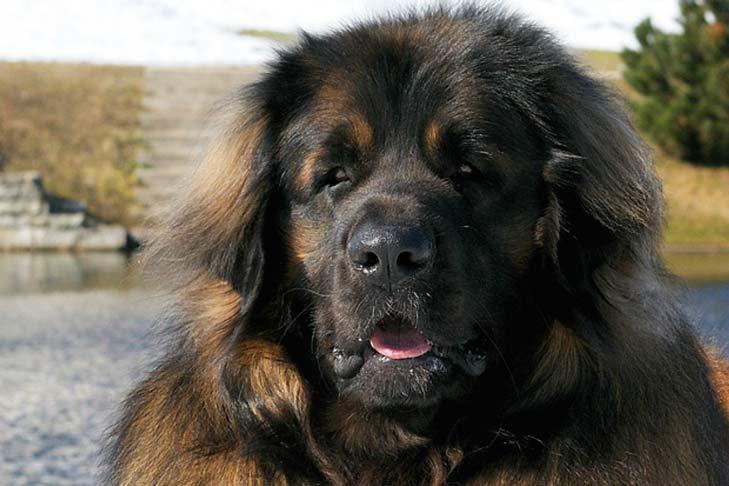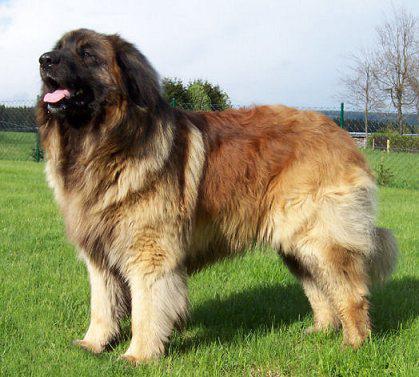The first image is the image on the left, the second image is the image on the right. Examine the images to the left and right. Is the description "A person is posed with one big dog that is standing with its body turned rightward." accurate? Answer yes or no. No. The first image is the image on the left, the second image is the image on the right. For the images shown, is this caption "A person is touching a dog" true? Answer yes or no. No. The first image is the image on the left, the second image is the image on the right. For the images shown, is this caption "A large dog is standing outdoors next to a human." true? Answer yes or no. No. 